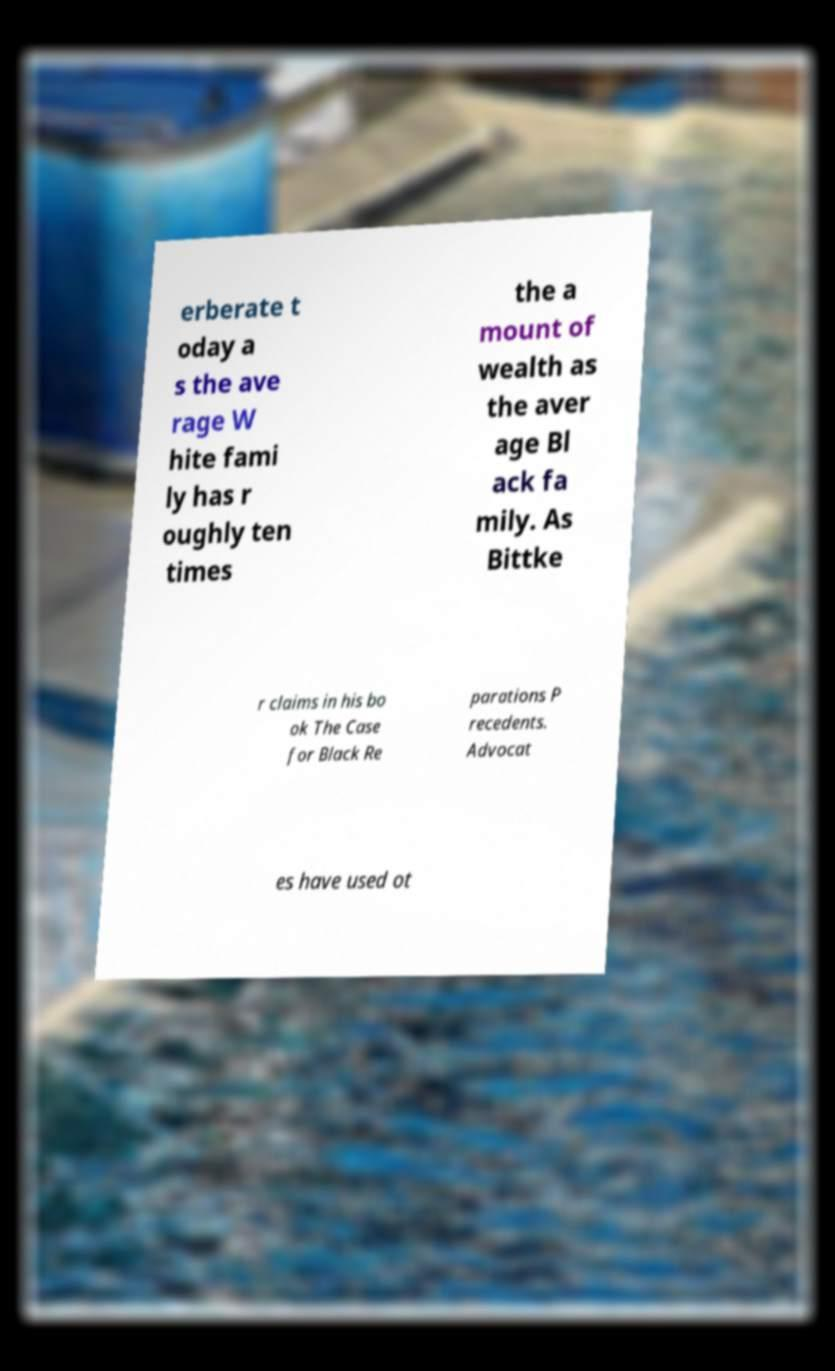There's text embedded in this image that I need extracted. Can you transcribe it verbatim? erberate t oday a s the ave rage W hite fami ly has r oughly ten times the a mount of wealth as the aver age Bl ack fa mily. As Bittke r claims in his bo ok The Case for Black Re parations P recedents. Advocat es have used ot 